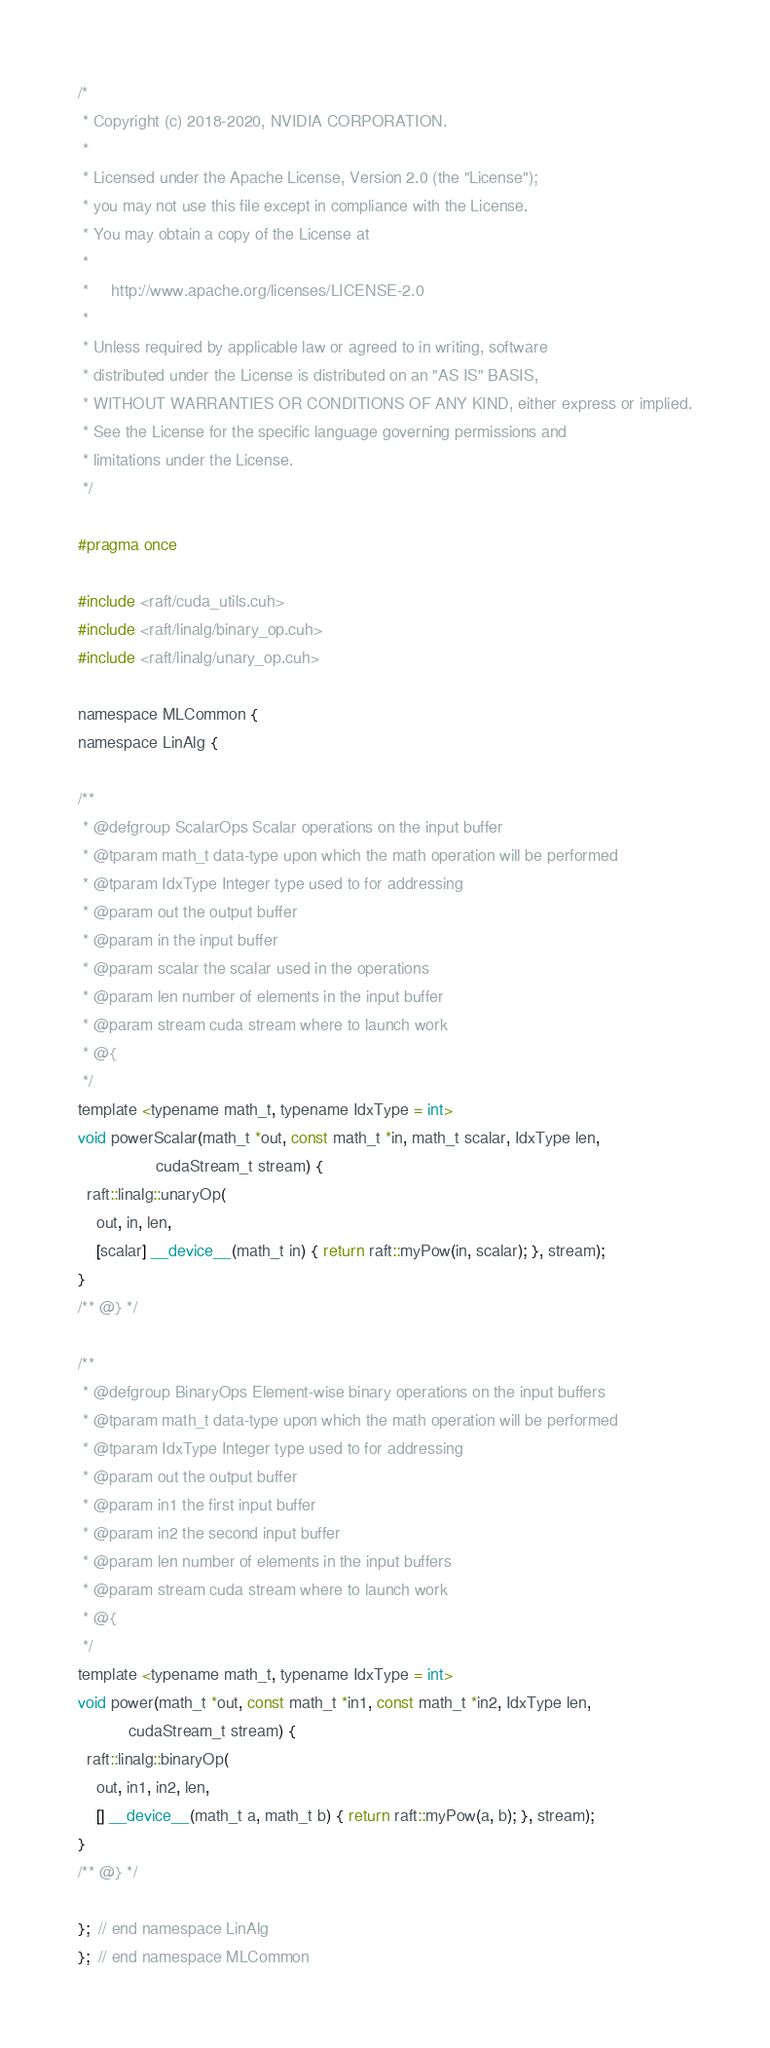Convert code to text. <code><loc_0><loc_0><loc_500><loc_500><_Cuda_>/*
 * Copyright (c) 2018-2020, NVIDIA CORPORATION.
 *
 * Licensed under the Apache License, Version 2.0 (the "License");
 * you may not use this file except in compliance with the License.
 * You may obtain a copy of the License at
 *
 *     http://www.apache.org/licenses/LICENSE-2.0
 *
 * Unless required by applicable law or agreed to in writing, software
 * distributed under the License is distributed on an "AS IS" BASIS,
 * WITHOUT WARRANTIES OR CONDITIONS OF ANY KIND, either express or implied.
 * See the License for the specific language governing permissions and
 * limitations under the License.
 */

#pragma once

#include <raft/cuda_utils.cuh>
#include <raft/linalg/binary_op.cuh>
#include <raft/linalg/unary_op.cuh>

namespace MLCommon {
namespace LinAlg {

/**
 * @defgroup ScalarOps Scalar operations on the input buffer
 * @tparam math_t data-type upon which the math operation will be performed
 * @tparam IdxType Integer type used to for addressing
 * @param out the output buffer
 * @param in the input buffer
 * @param scalar the scalar used in the operations
 * @param len number of elements in the input buffer
 * @param stream cuda stream where to launch work
 * @{
 */
template <typename math_t, typename IdxType = int>
void powerScalar(math_t *out, const math_t *in, math_t scalar, IdxType len,
                 cudaStream_t stream) {
  raft::linalg::unaryOp(
    out, in, len,
    [scalar] __device__(math_t in) { return raft::myPow(in, scalar); }, stream);
}
/** @} */

/**
 * @defgroup BinaryOps Element-wise binary operations on the input buffers
 * @tparam math_t data-type upon which the math operation will be performed
 * @tparam IdxType Integer type used to for addressing
 * @param out the output buffer
 * @param in1 the first input buffer
 * @param in2 the second input buffer
 * @param len number of elements in the input buffers
 * @param stream cuda stream where to launch work
 * @{
 */
template <typename math_t, typename IdxType = int>
void power(math_t *out, const math_t *in1, const math_t *in2, IdxType len,
           cudaStream_t stream) {
  raft::linalg::binaryOp(
    out, in1, in2, len,
    [] __device__(math_t a, math_t b) { return raft::myPow(a, b); }, stream);
}
/** @} */

};  // end namespace LinAlg
};  // end namespace MLCommon
</code> 